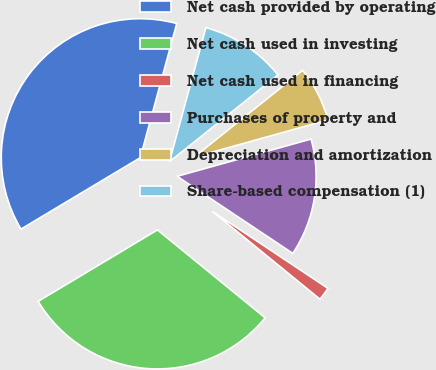Convert chart to OTSL. <chart><loc_0><loc_0><loc_500><loc_500><pie_chart><fcel>Net cash provided by operating<fcel>Net cash used in investing<fcel>Net cash used in financing<fcel>Purchases of property and<fcel>Depreciation and amortization<fcel>Share-based compensation (1)<nl><fcel>37.81%<fcel>30.52%<fcel>1.54%<fcel>13.67%<fcel>6.42%<fcel>10.04%<nl></chart> 